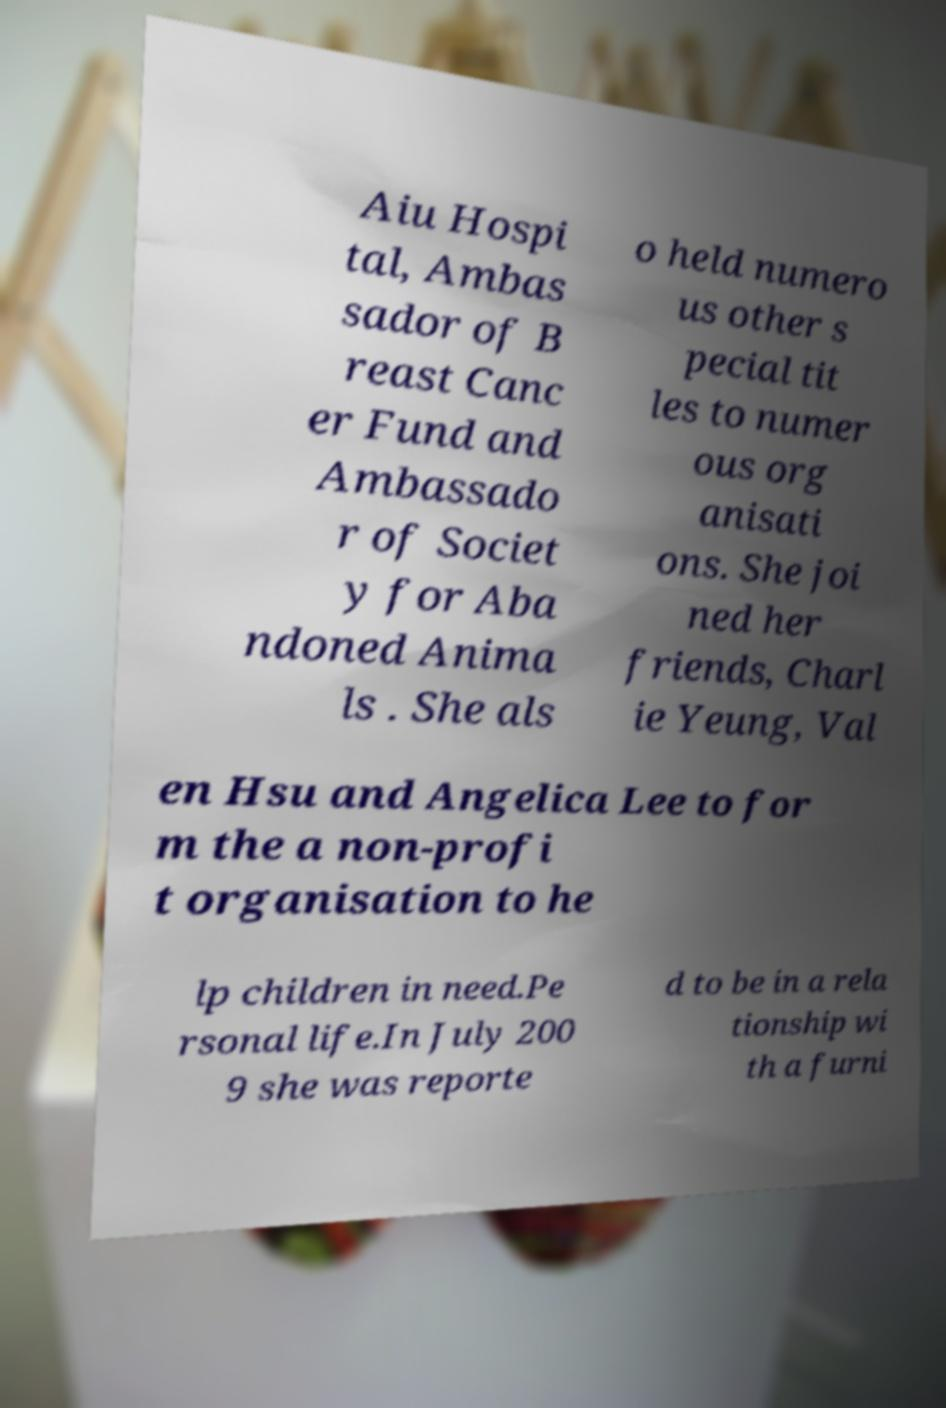Could you assist in decoding the text presented in this image and type it out clearly? Aiu Hospi tal, Ambas sador of B reast Canc er Fund and Ambassado r of Societ y for Aba ndoned Anima ls . She als o held numero us other s pecial tit les to numer ous org anisati ons. She joi ned her friends, Charl ie Yeung, Val en Hsu and Angelica Lee to for m the a non-profi t organisation to he lp children in need.Pe rsonal life.In July 200 9 she was reporte d to be in a rela tionship wi th a furni 